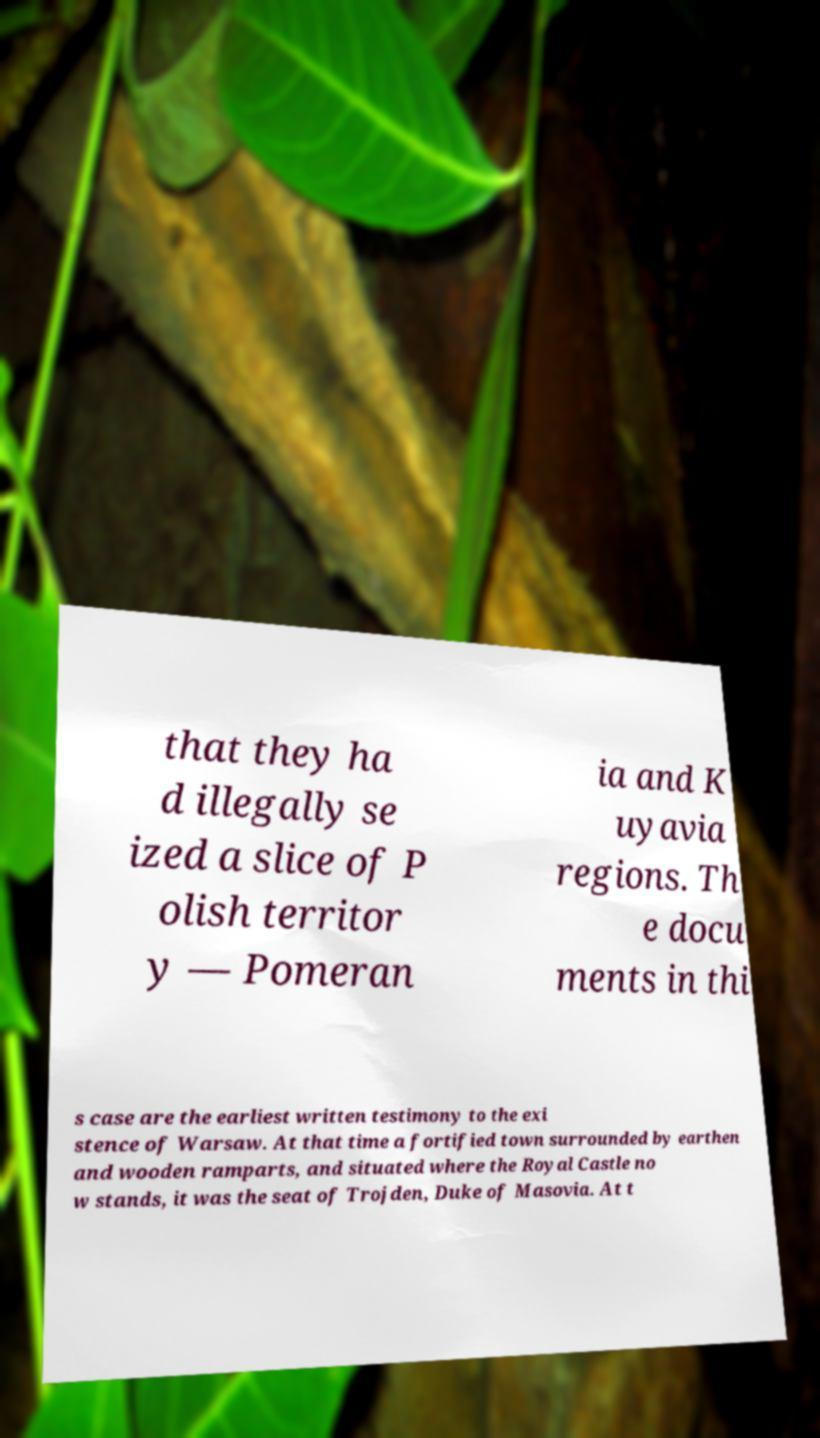Could you assist in decoding the text presented in this image and type it out clearly? that they ha d illegally se ized a slice of P olish territor y — Pomeran ia and K uyavia regions. Th e docu ments in thi s case are the earliest written testimony to the exi stence of Warsaw. At that time a fortified town surrounded by earthen and wooden ramparts, and situated where the Royal Castle no w stands, it was the seat of Trojden, Duke of Masovia. At t 